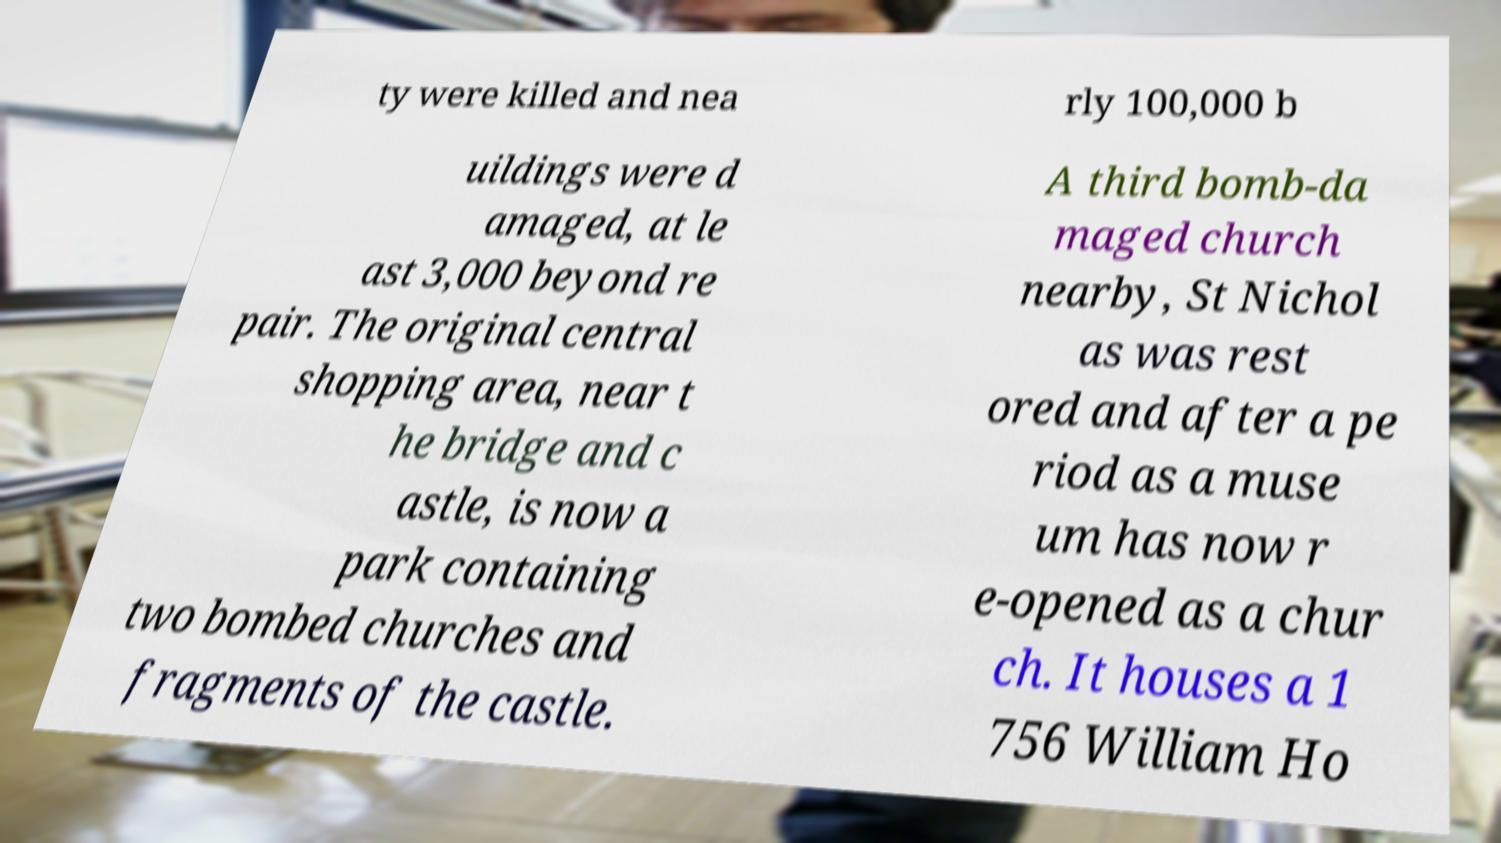Can you accurately transcribe the text from the provided image for me? ty were killed and nea rly 100,000 b uildings were d amaged, at le ast 3,000 beyond re pair. The original central shopping area, near t he bridge and c astle, is now a park containing two bombed churches and fragments of the castle. A third bomb-da maged church nearby, St Nichol as was rest ored and after a pe riod as a muse um has now r e-opened as a chur ch. It houses a 1 756 William Ho 